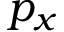<formula> <loc_0><loc_0><loc_500><loc_500>p _ { x }</formula> 